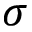Convert formula to latex. <formula><loc_0><loc_0><loc_500><loc_500>\sigma</formula> 